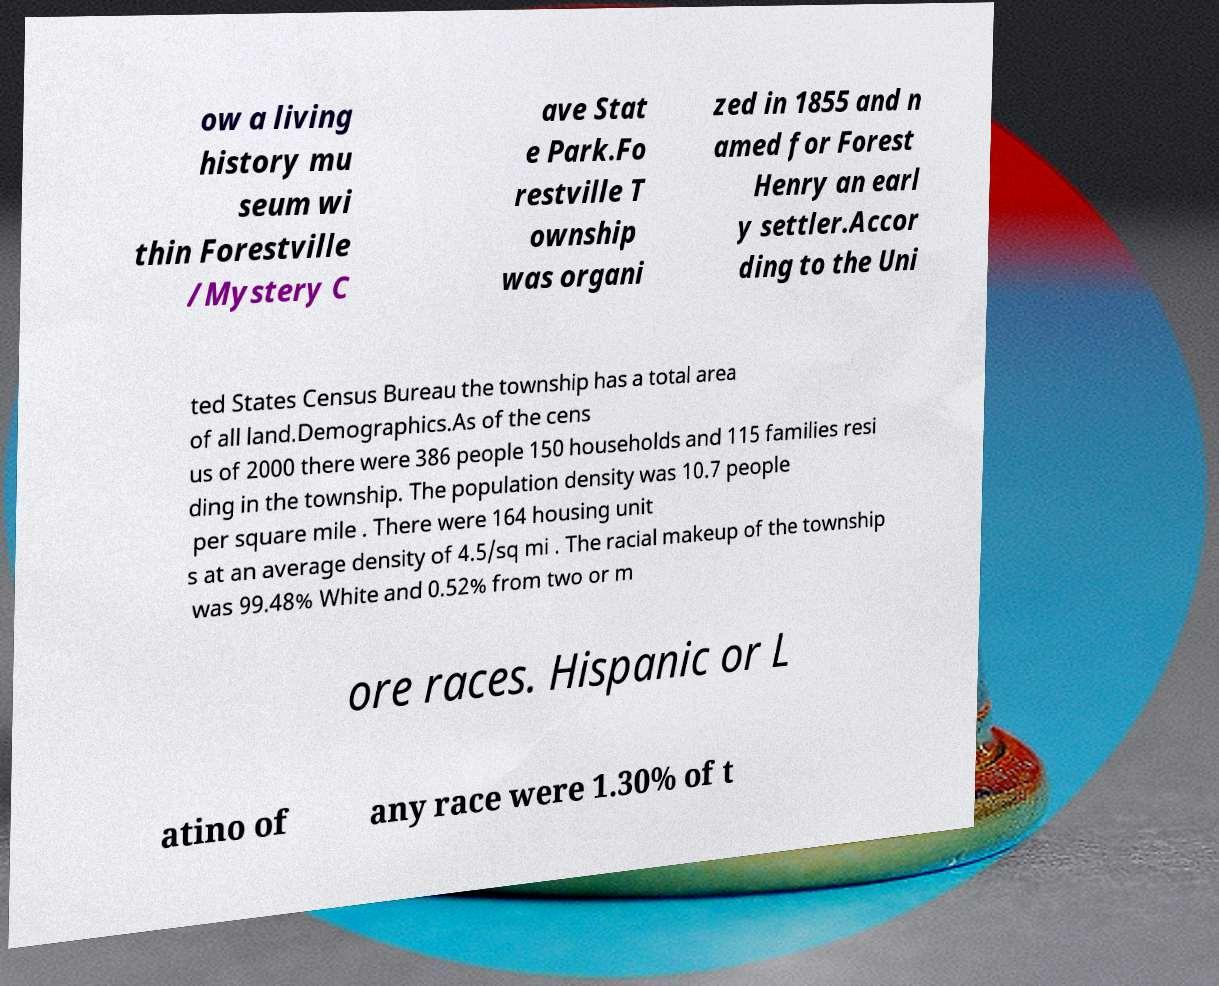What messages or text are displayed in this image? I need them in a readable, typed format. ow a living history mu seum wi thin Forestville /Mystery C ave Stat e Park.Fo restville T ownship was organi zed in 1855 and n amed for Forest Henry an earl y settler.Accor ding to the Uni ted States Census Bureau the township has a total area of all land.Demographics.As of the cens us of 2000 there were 386 people 150 households and 115 families resi ding in the township. The population density was 10.7 people per square mile . There were 164 housing unit s at an average density of 4.5/sq mi . The racial makeup of the township was 99.48% White and 0.52% from two or m ore races. Hispanic or L atino of any race were 1.30% of t 